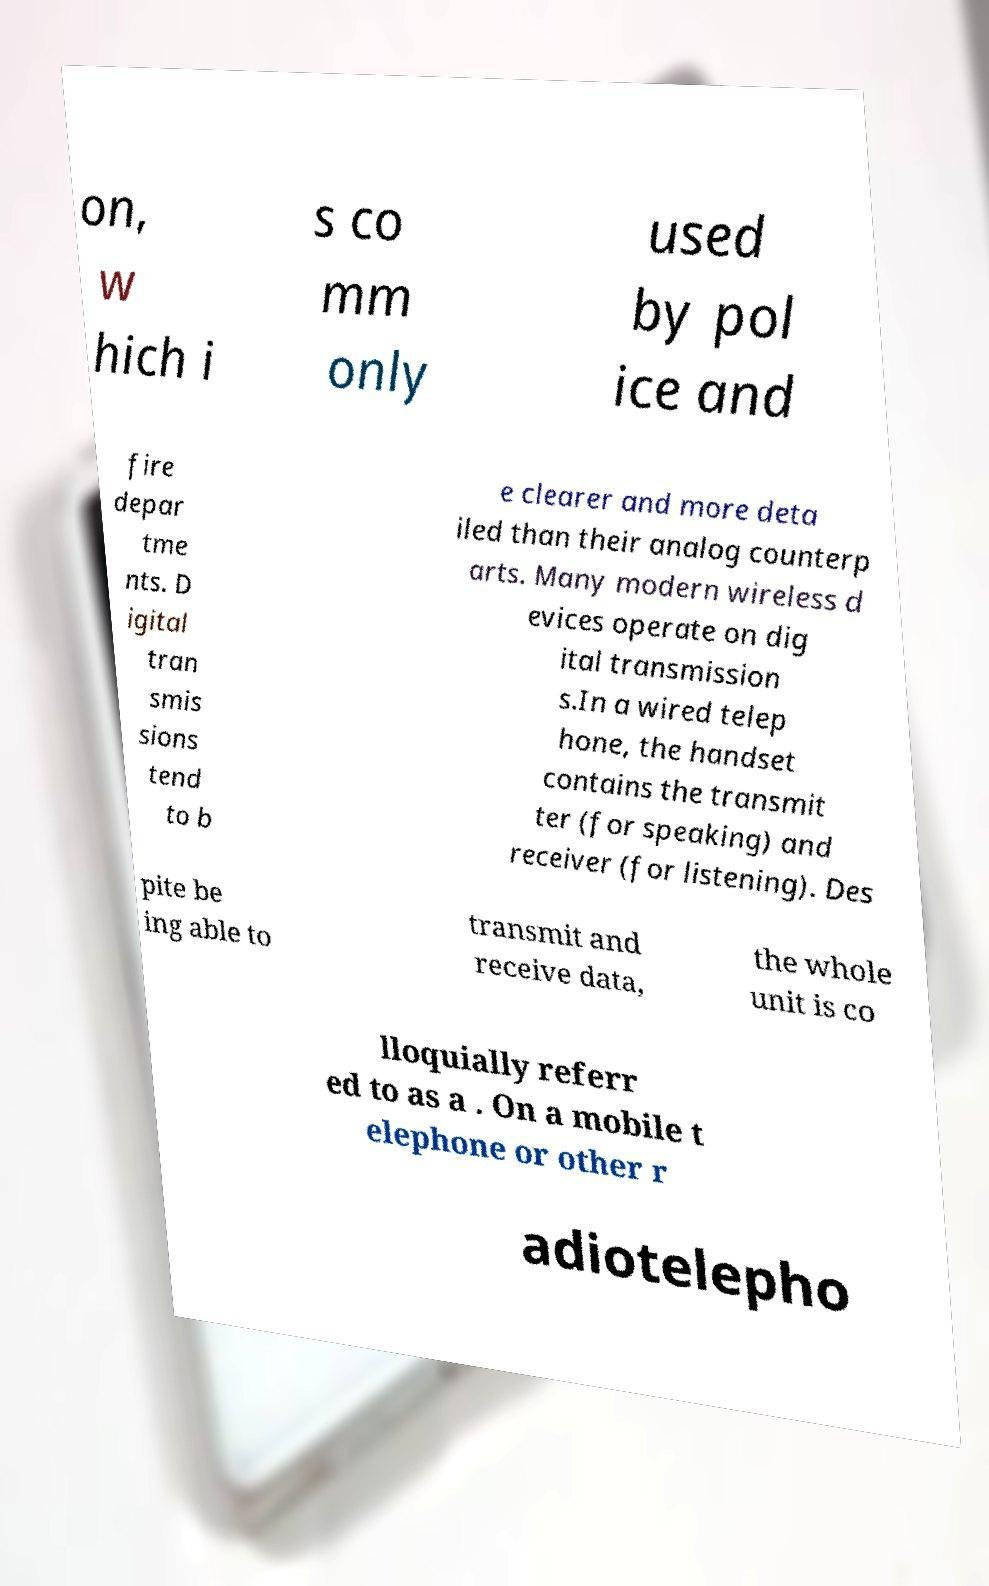Can you read and provide the text displayed in the image?This photo seems to have some interesting text. Can you extract and type it out for me? on, w hich i s co mm only used by pol ice and fire depar tme nts. D igital tran smis sions tend to b e clearer and more deta iled than their analog counterp arts. Many modern wireless d evices operate on dig ital transmission s.In a wired telep hone, the handset contains the transmit ter (for speaking) and receiver (for listening). Des pite be ing able to transmit and receive data, the whole unit is co lloquially referr ed to as a . On a mobile t elephone or other r adiotelepho 